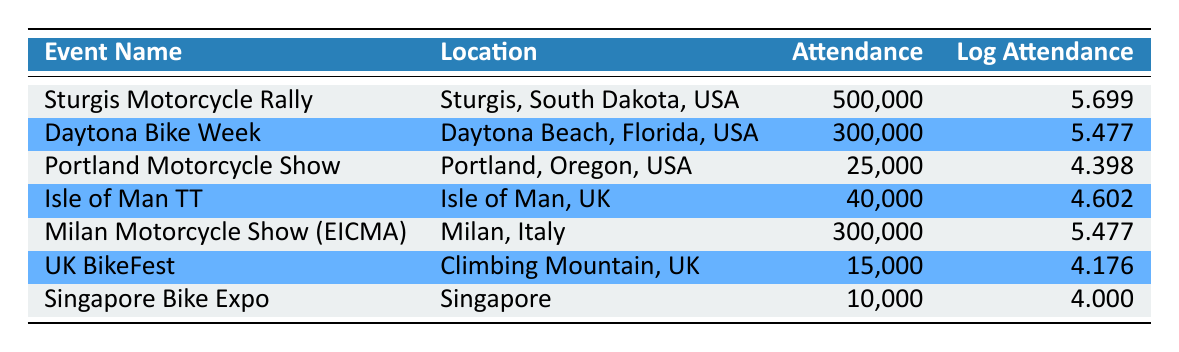What is the attendance for the Sturgis Motorcycle Rally? According to the table, the attendance for the Sturgis Motorcycle Rally is directly listed as 500,000.
Answer: 500,000 Which event has the highest logarithmic attendance? By comparing the logarithmic attendance values listed, Sturgis Motorcycle Rally has the highest value at 5.699.
Answer: Sturgis Motorcycle Rally How many events have an attendance greater than 40,000? By filtering through the attendance values in the table, the events with attendance greater than 40,000 are Sturgis Motorcycle Rally (500,000), Daytona Bike Week (300,000), Milan Motorcycle Show (300,000), and Isle of Man TT (40,000). This totals four events.
Answer: 4 What is the difference in attendance between the Daytona Bike Week and the Portland Motorcycle Show? The attendance for Daytona Bike Week is 300,000 and for Portland Motorcycle Show is 25,000. The difference is 300,000 - 25,000 = 275,000.
Answer: 275,000 Is the attendance for UK BikeFest greater than the attendance for Singapore Bike Expo? The attendance for UK BikeFest is 15,000, and for Singapore Bike Expo, it is 10,000. Since 15,000 is greater than 10,000, the answer is yes.
Answer: Yes What is the average attendance across all the events listed? To calculate the average attendance, we sum up the attendance values: 500,000 + 300,000 + 25,000 + 40,000 + 300,000 + 15,000 + 10,000 = 1,190,000. Then, divide this total by the number of events (7): 1,190,000 / 7 = 170,000.
Answer: 170,000 Are there any events with an attendance of less than 20,000? By examining the attendance numbers in the table, both UK BikeFest (15,000) and Singapore Bike Expo (10,000) have attendance numbers less than 20,000. Thus, the answer is yes.
Answer: Yes Which two events have the same logarithmic attendance value? Upon reviewing the table, Daytona Bike Week and Milan Motorcycle Show both have a logarithmic attendance of 5.477.
Answer: Daytona Bike Week and Milan Motorcycle Show 